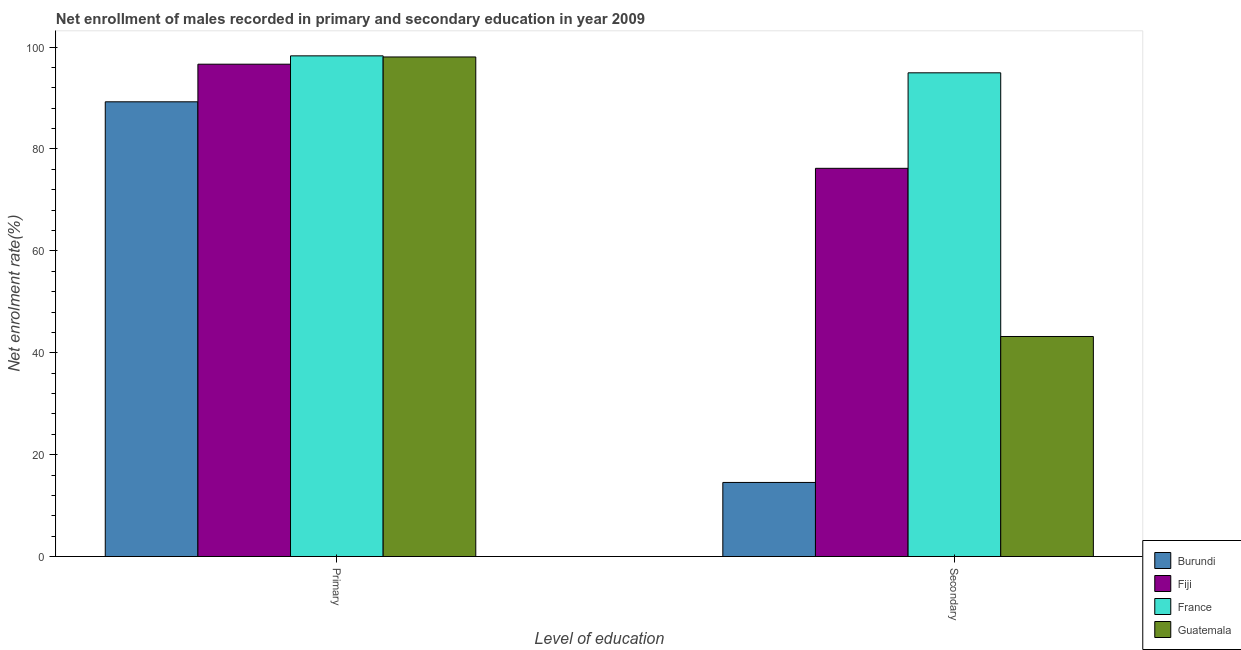How many groups of bars are there?
Your answer should be very brief. 2. Are the number of bars per tick equal to the number of legend labels?
Make the answer very short. Yes. Are the number of bars on each tick of the X-axis equal?
Provide a short and direct response. Yes. What is the label of the 1st group of bars from the left?
Your answer should be compact. Primary. What is the enrollment rate in secondary education in France?
Your answer should be very brief. 94.96. Across all countries, what is the maximum enrollment rate in secondary education?
Offer a very short reply. 94.96. Across all countries, what is the minimum enrollment rate in primary education?
Provide a short and direct response. 89.27. In which country was the enrollment rate in secondary education maximum?
Provide a succinct answer. France. In which country was the enrollment rate in secondary education minimum?
Provide a short and direct response. Burundi. What is the total enrollment rate in secondary education in the graph?
Your answer should be compact. 228.9. What is the difference between the enrollment rate in primary education in Fiji and that in France?
Ensure brevity in your answer.  -1.64. What is the difference between the enrollment rate in secondary education in Fiji and the enrollment rate in primary education in France?
Keep it short and to the point. -22.08. What is the average enrollment rate in primary education per country?
Make the answer very short. 95.57. What is the difference between the enrollment rate in primary education and enrollment rate in secondary education in Fiji?
Make the answer very short. 20.44. In how many countries, is the enrollment rate in primary education greater than 76 %?
Your answer should be compact. 4. What is the ratio of the enrollment rate in secondary education in France to that in Guatemala?
Ensure brevity in your answer.  2.2. In how many countries, is the enrollment rate in primary education greater than the average enrollment rate in primary education taken over all countries?
Give a very brief answer. 3. What does the 3rd bar from the left in Secondary represents?
Make the answer very short. France. What does the 4th bar from the right in Secondary represents?
Provide a succinct answer. Burundi. Are all the bars in the graph horizontal?
Make the answer very short. No. What is the difference between two consecutive major ticks on the Y-axis?
Offer a terse response. 20. Are the values on the major ticks of Y-axis written in scientific E-notation?
Make the answer very short. No. Does the graph contain grids?
Your response must be concise. No. Where does the legend appear in the graph?
Provide a succinct answer. Bottom right. How many legend labels are there?
Your response must be concise. 4. What is the title of the graph?
Provide a succinct answer. Net enrollment of males recorded in primary and secondary education in year 2009. Does "Kyrgyz Republic" appear as one of the legend labels in the graph?
Your answer should be very brief. No. What is the label or title of the X-axis?
Your response must be concise. Level of education. What is the label or title of the Y-axis?
Offer a very short reply. Net enrolment rate(%). What is the Net enrolment rate(%) of Burundi in Primary?
Make the answer very short. 89.27. What is the Net enrolment rate(%) in Fiji in Primary?
Provide a short and direct response. 96.65. What is the Net enrolment rate(%) in France in Primary?
Offer a terse response. 98.28. What is the Net enrolment rate(%) of Guatemala in Primary?
Offer a very short reply. 98.07. What is the Net enrolment rate(%) in Burundi in Secondary?
Your response must be concise. 14.54. What is the Net enrolment rate(%) in Fiji in Secondary?
Provide a succinct answer. 76.21. What is the Net enrolment rate(%) in France in Secondary?
Provide a succinct answer. 94.96. What is the Net enrolment rate(%) in Guatemala in Secondary?
Your response must be concise. 43.19. Across all Level of education, what is the maximum Net enrolment rate(%) in Burundi?
Your answer should be very brief. 89.27. Across all Level of education, what is the maximum Net enrolment rate(%) of Fiji?
Offer a terse response. 96.65. Across all Level of education, what is the maximum Net enrolment rate(%) of France?
Offer a terse response. 98.28. Across all Level of education, what is the maximum Net enrolment rate(%) of Guatemala?
Your answer should be very brief. 98.07. Across all Level of education, what is the minimum Net enrolment rate(%) in Burundi?
Provide a succinct answer. 14.54. Across all Level of education, what is the minimum Net enrolment rate(%) of Fiji?
Your response must be concise. 76.21. Across all Level of education, what is the minimum Net enrolment rate(%) of France?
Give a very brief answer. 94.96. Across all Level of education, what is the minimum Net enrolment rate(%) of Guatemala?
Offer a terse response. 43.19. What is the total Net enrolment rate(%) in Burundi in the graph?
Provide a short and direct response. 103.81. What is the total Net enrolment rate(%) of Fiji in the graph?
Offer a terse response. 172.85. What is the total Net enrolment rate(%) in France in the graph?
Offer a terse response. 193.24. What is the total Net enrolment rate(%) of Guatemala in the graph?
Your answer should be very brief. 141.26. What is the difference between the Net enrolment rate(%) of Burundi in Primary and that in Secondary?
Your response must be concise. 74.72. What is the difference between the Net enrolment rate(%) in Fiji in Primary and that in Secondary?
Your answer should be very brief. 20.44. What is the difference between the Net enrolment rate(%) of France in Primary and that in Secondary?
Offer a very short reply. 3.33. What is the difference between the Net enrolment rate(%) of Guatemala in Primary and that in Secondary?
Offer a terse response. 54.87. What is the difference between the Net enrolment rate(%) in Burundi in Primary and the Net enrolment rate(%) in Fiji in Secondary?
Your answer should be very brief. 13.06. What is the difference between the Net enrolment rate(%) in Burundi in Primary and the Net enrolment rate(%) in France in Secondary?
Your answer should be very brief. -5.69. What is the difference between the Net enrolment rate(%) of Burundi in Primary and the Net enrolment rate(%) of Guatemala in Secondary?
Keep it short and to the point. 46.07. What is the difference between the Net enrolment rate(%) of Fiji in Primary and the Net enrolment rate(%) of France in Secondary?
Make the answer very short. 1.69. What is the difference between the Net enrolment rate(%) of Fiji in Primary and the Net enrolment rate(%) of Guatemala in Secondary?
Your response must be concise. 53.45. What is the difference between the Net enrolment rate(%) in France in Primary and the Net enrolment rate(%) in Guatemala in Secondary?
Your answer should be compact. 55.09. What is the average Net enrolment rate(%) of Burundi per Level of education?
Your answer should be very brief. 51.9. What is the average Net enrolment rate(%) of Fiji per Level of education?
Your answer should be very brief. 86.43. What is the average Net enrolment rate(%) of France per Level of education?
Offer a terse response. 96.62. What is the average Net enrolment rate(%) of Guatemala per Level of education?
Your answer should be very brief. 70.63. What is the difference between the Net enrolment rate(%) in Burundi and Net enrolment rate(%) in Fiji in Primary?
Keep it short and to the point. -7.38. What is the difference between the Net enrolment rate(%) of Burundi and Net enrolment rate(%) of France in Primary?
Offer a very short reply. -9.02. What is the difference between the Net enrolment rate(%) in Burundi and Net enrolment rate(%) in Guatemala in Primary?
Your response must be concise. -8.8. What is the difference between the Net enrolment rate(%) in Fiji and Net enrolment rate(%) in France in Primary?
Offer a very short reply. -1.64. What is the difference between the Net enrolment rate(%) in Fiji and Net enrolment rate(%) in Guatemala in Primary?
Provide a succinct answer. -1.42. What is the difference between the Net enrolment rate(%) of France and Net enrolment rate(%) of Guatemala in Primary?
Provide a short and direct response. 0.22. What is the difference between the Net enrolment rate(%) of Burundi and Net enrolment rate(%) of Fiji in Secondary?
Give a very brief answer. -61.67. What is the difference between the Net enrolment rate(%) in Burundi and Net enrolment rate(%) in France in Secondary?
Keep it short and to the point. -80.41. What is the difference between the Net enrolment rate(%) of Burundi and Net enrolment rate(%) of Guatemala in Secondary?
Your answer should be very brief. -28.65. What is the difference between the Net enrolment rate(%) in Fiji and Net enrolment rate(%) in France in Secondary?
Your answer should be very brief. -18.75. What is the difference between the Net enrolment rate(%) in Fiji and Net enrolment rate(%) in Guatemala in Secondary?
Your answer should be very brief. 33.01. What is the difference between the Net enrolment rate(%) in France and Net enrolment rate(%) in Guatemala in Secondary?
Ensure brevity in your answer.  51.76. What is the ratio of the Net enrolment rate(%) in Burundi in Primary to that in Secondary?
Ensure brevity in your answer.  6.14. What is the ratio of the Net enrolment rate(%) of Fiji in Primary to that in Secondary?
Provide a succinct answer. 1.27. What is the ratio of the Net enrolment rate(%) of France in Primary to that in Secondary?
Keep it short and to the point. 1.04. What is the ratio of the Net enrolment rate(%) in Guatemala in Primary to that in Secondary?
Offer a terse response. 2.27. What is the difference between the highest and the second highest Net enrolment rate(%) in Burundi?
Ensure brevity in your answer.  74.72. What is the difference between the highest and the second highest Net enrolment rate(%) of Fiji?
Keep it short and to the point. 20.44. What is the difference between the highest and the second highest Net enrolment rate(%) in France?
Make the answer very short. 3.33. What is the difference between the highest and the second highest Net enrolment rate(%) in Guatemala?
Ensure brevity in your answer.  54.87. What is the difference between the highest and the lowest Net enrolment rate(%) of Burundi?
Offer a very short reply. 74.72. What is the difference between the highest and the lowest Net enrolment rate(%) in Fiji?
Give a very brief answer. 20.44. What is the difference between the highest and the lowest Net enrolment rate(%) of France?
Provide a succinct answer. 3.33. What is the difference between the highest and the lowest Net enrolment rate(%) in Guatemala?
Your answer should be very brief. 54.87. 